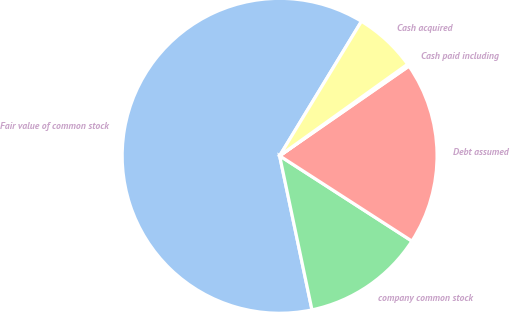Convert chart to OTSL. <chart><loc_0><loc_0><loc_500><loc_500><pie_chart><fcel>Fair value of common stock<fcel>company common stock<fcel>Debt assumed<fcel>Cash paid including<fcel>Cash acquired<nl><fcel>61.99%<fcel>12.59%<fcel>18.76%<fcel>0.24%<fcel>6.41%<nl></chart> 